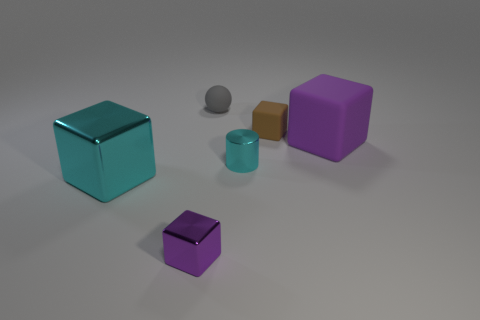Add 2 large purple cubes. How many objects exist? 8 Subtract all cylinders. How many objects are left? 5 Subtract all large purple matte things. Subtract all tiny cyan metallic things. How many objects are left? 4 Add 3 large cyan objects. How many large cyan objects are left? 4 Add 1 large blue metallic things. How many large blue metallic things exist? 1 Subtract 0 yellow blocks. How many objects are left? 6 